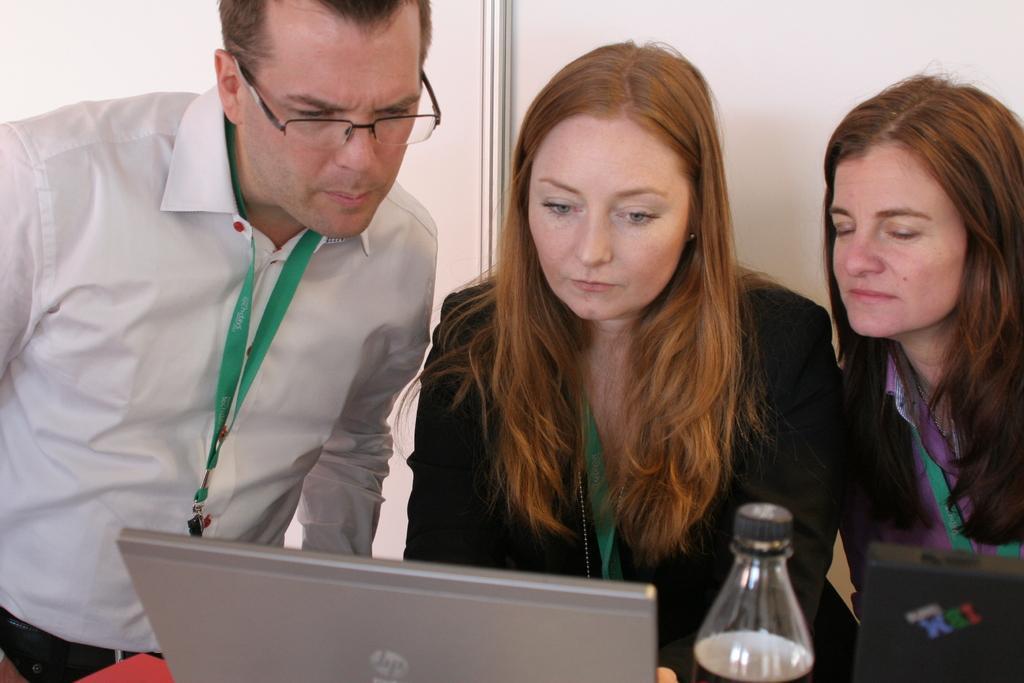How would you summarize this image in a sentence or two? There are three people wore tags and we can see laptop, black object and bottle on the platform. In the background of the image we can see wall. 